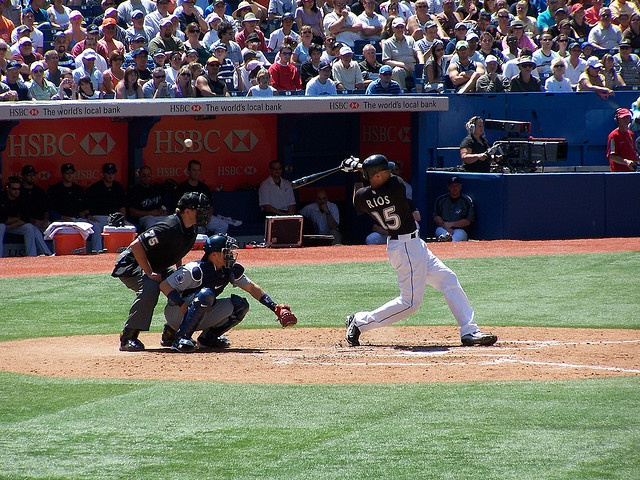Describe the objects in this image and their specific colors. I can see people in darkblue, darkgray, black, and white tones, people in darkblue, black, maroon, gray, and navy tones, people in darkblue, black, maroon, gray, and darkgray tones, people in darkblue, black, navy, maroon, and gray tones, and people in darkblue, black, blue, and navy tones in this image. 